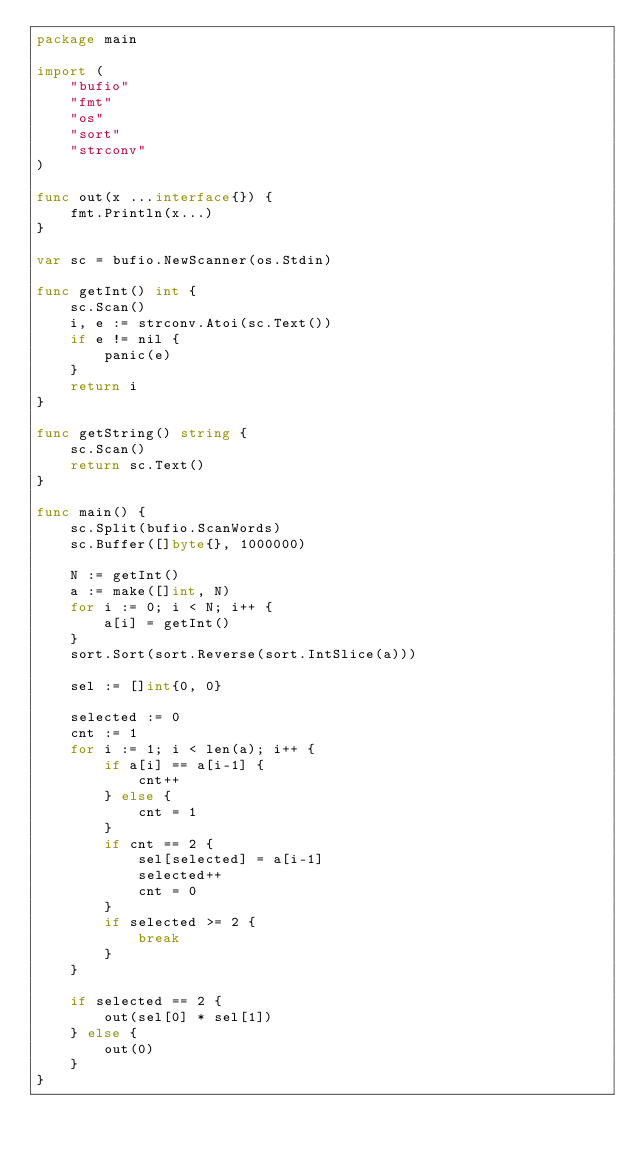<code> <loc_0><loc_0><loc_500><loc_500><_Go_>package main

import (
	"bufio"
	"fmt"
	"os"
	"sort"
	"strconv"
)

func out(x ...interface{}) {
	fmt.Println(x...)
}

var sc = bufio.NewScanner(os.Stdin)

func getInt() int {
	sc.Scan()
	i, e := strconv.Atoi(sc.Text())
	if e != nil {
		panic(e)
	}
	return i
}

func getString() string {
	sc.Scan()
	return sc.Text()
}

func main() {
	sc.Split(bufio.ScanWords)
	sc.Buffer([]byte{}, 1000000)

	N := getInt()
	a := make([]int, N)
	for i := 0; i < N; i++ {
		a[i] = getInt()
	}
	sort.Sort(sort.Reverse(sort.IntSlice(a)))

	sel := []int{0, 0}

	selected := 0
	cnt := 1
	for i := 1; i < len(a); i++ {
		if a[i] == a[i-1] {
			cnt++
		} else {
			cnt = 1
		}
		if cnt == 2 {
			sel[selected] = a[i-1]
			selected++
			cnt = 0
		}
		if selected >= 2 {
			break
		}
	}

	if selected == 2 {
		out(sel[0] * sel[1])
	} else {
		out(0)
	}
}
</code> 